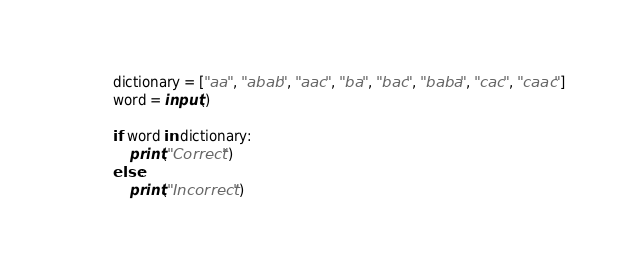<code> <loc_0><loc_0><loc_500><loc_500><_Python_>dictionary = ["aa", "abab", "aac", "ba", "bac", "baba", "cac", "caac"]
word = input()

if word in dictionary:
    print("Correct")
else:
    print("Incorrect")
</code> 